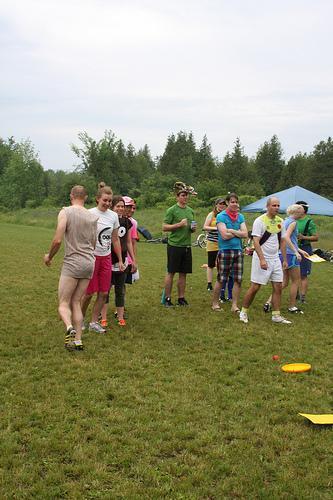How many tents are in photo?
Give a very brief answer. 1. 